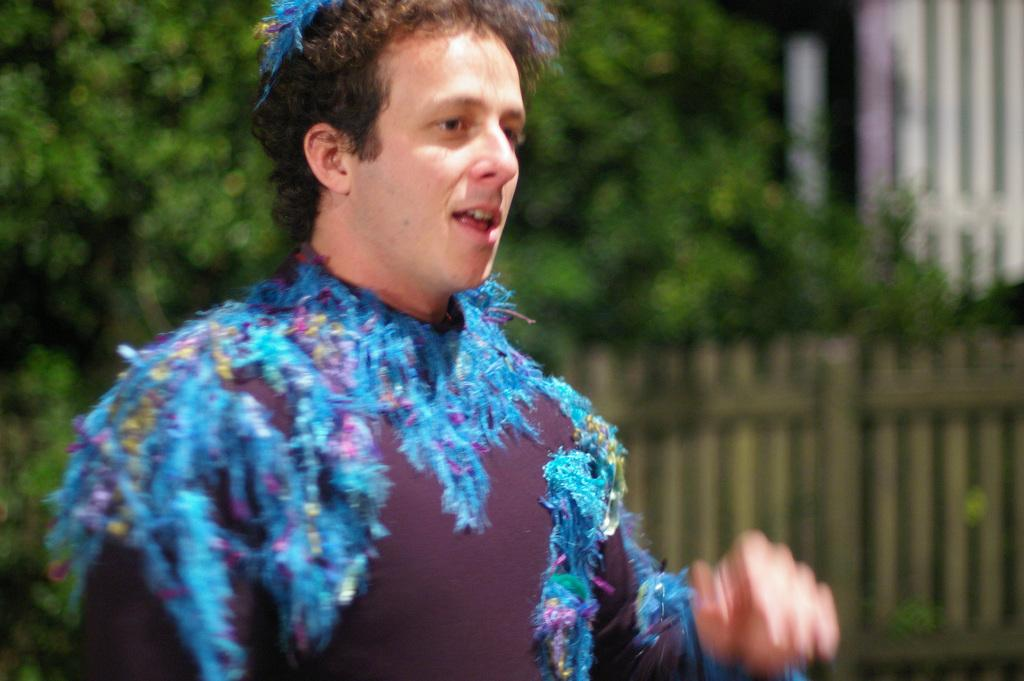What is the main subject in the front of the image? There is a person standing in the front of the image. What can be seen in the background of the image? There are trees and a wooden fence in the background of the image. What type of pot is the secretary using to create the wooden fence in the image? There is no secretary or pot present in the image, and the wooden fence is not being created in the image. 